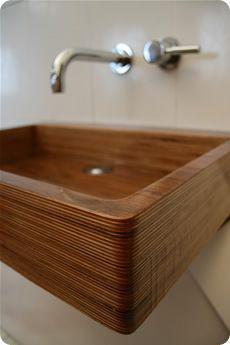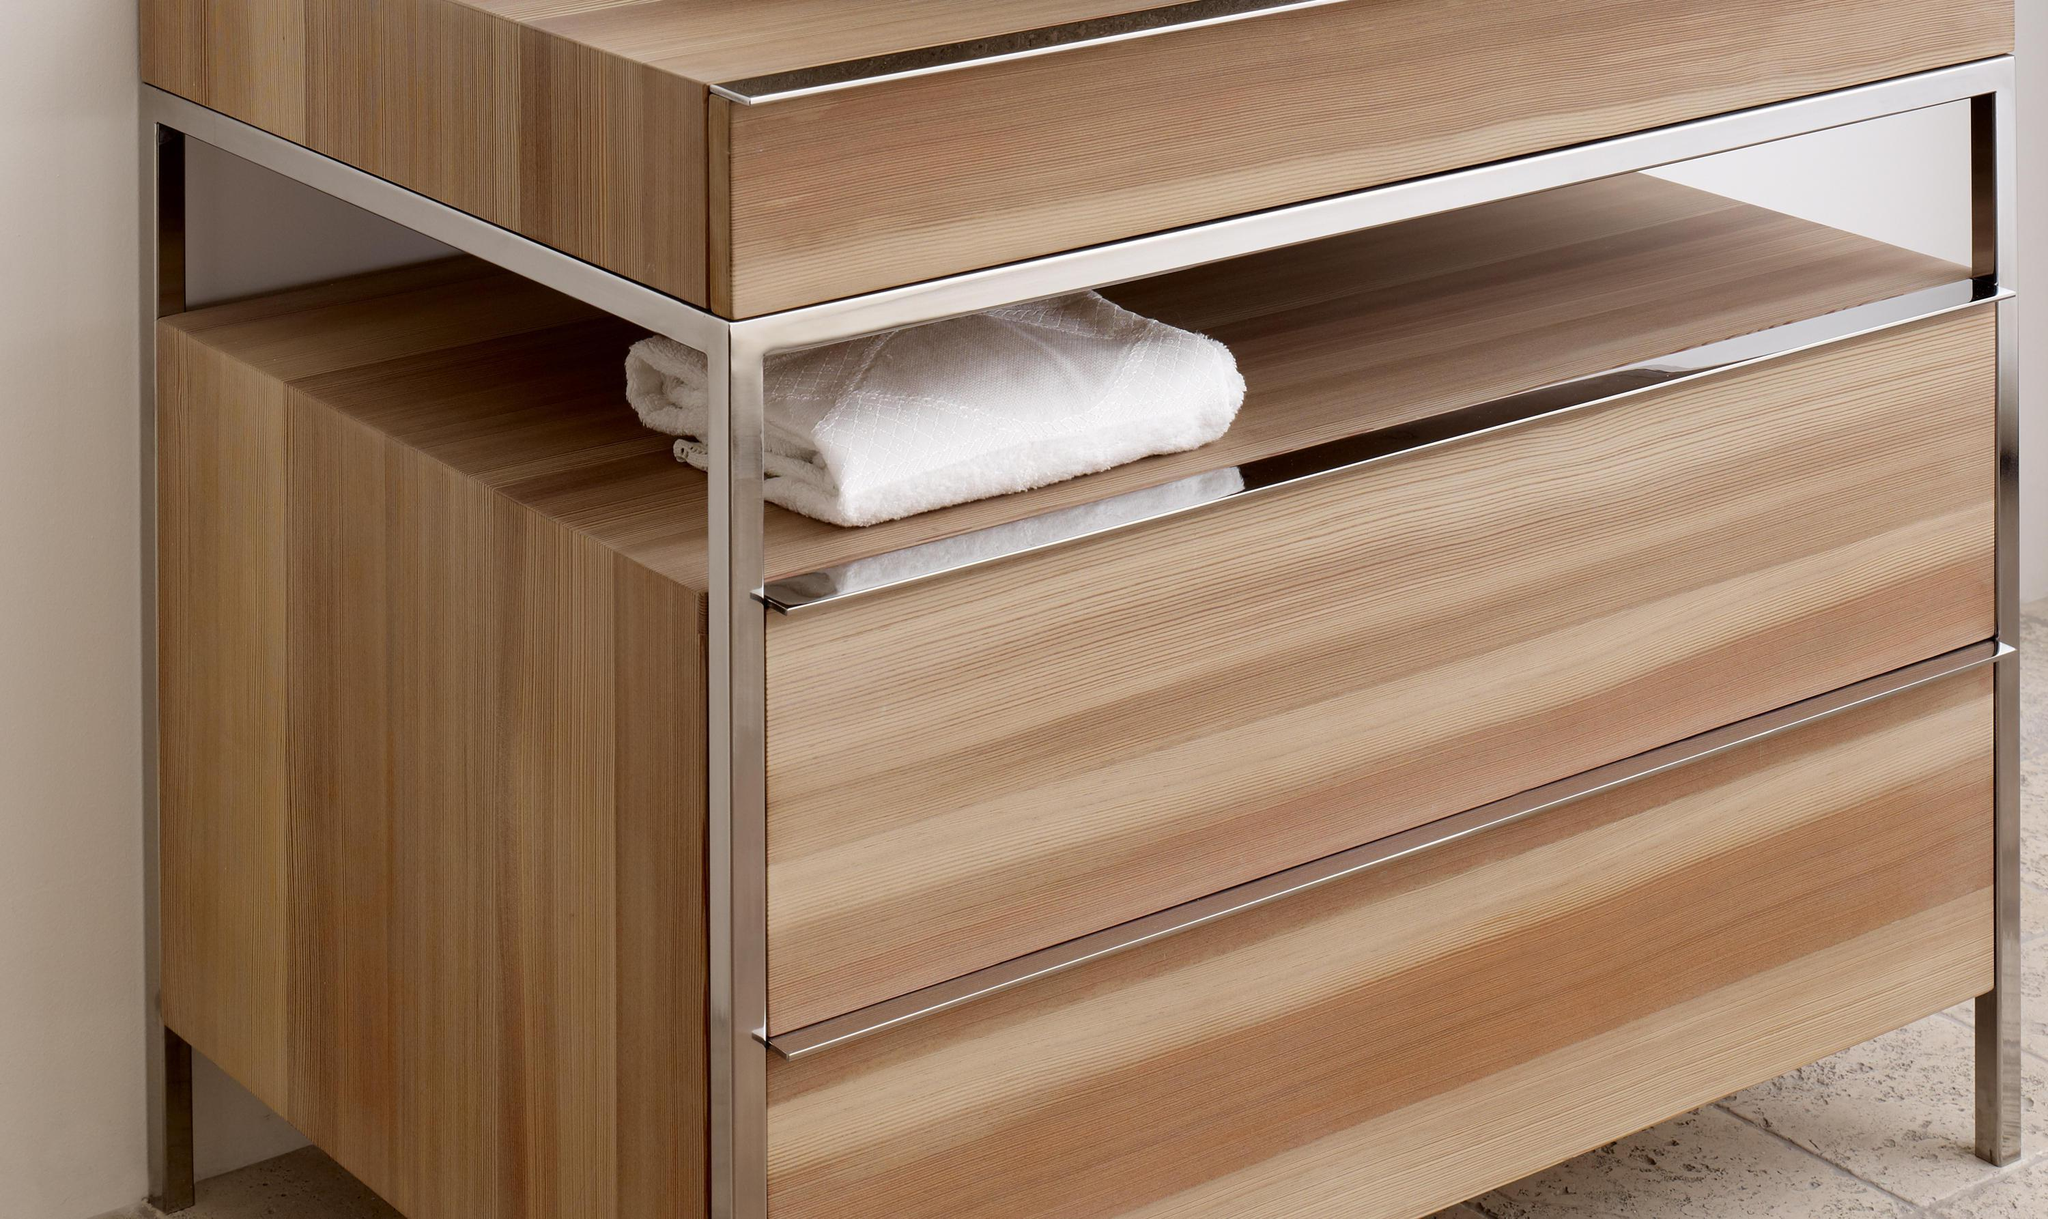The first image is the image on the left, the second image is the image on the right. Considering the images on both sides, is "An image shows a wall-mounted faucet and spout above a sink with a rectangular woodgrain basin." valid? Answer yes or no. Yes. The first image is the image on the left, the second image is the image on the right. Considering the images on both sides, is "There are two sinks with faucets and bowls." valid? Answer yes or no. No. 